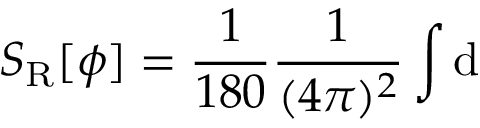<formula> <loc_0><loc_0><loc_500><loc_500>S _ { R } [ \phi ] = \frac { 1 } { 1 8 0 } \frac { 1 } { ( 4 \pi ) ^ { 2 } } \int d</formula> 